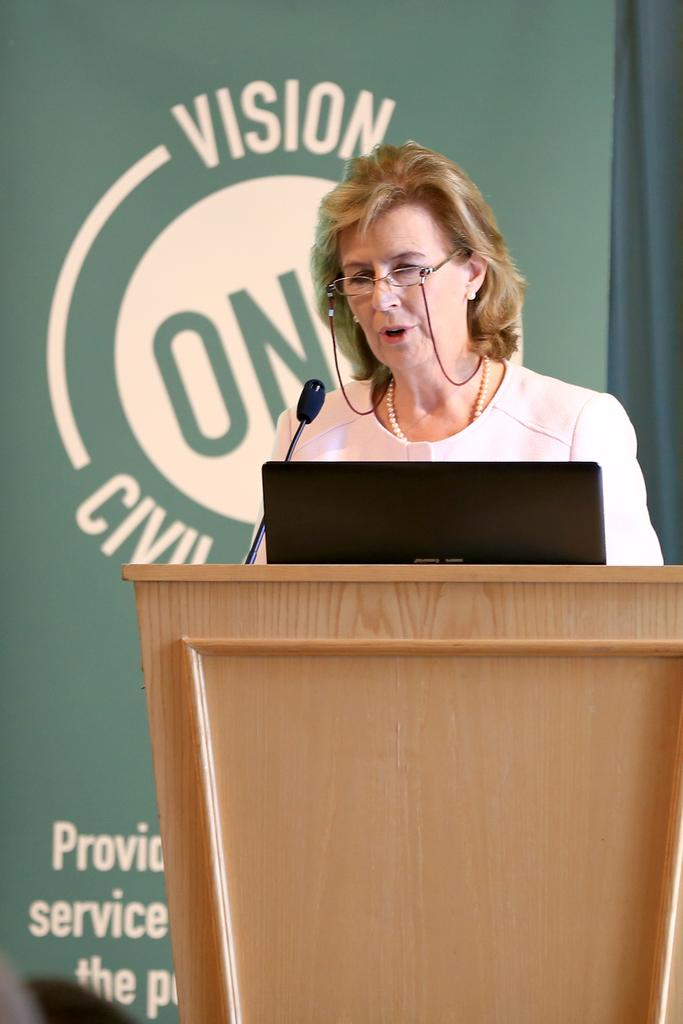Who is the main subject in the image? There is a woman in the image. What is the woman doing in the image? The woman is talking on a microphone. Can you describe the woman's appearance? The woman is wearing spectacles. What other objects can be seen in the image? There is a podium, a laptop, and a banner in the background. What type of polish is the woman applying to the marble in the image? There is no polish or marble present in the image. How does the woman drive the car in the image? There is no car or driving activity depicted in the image. 